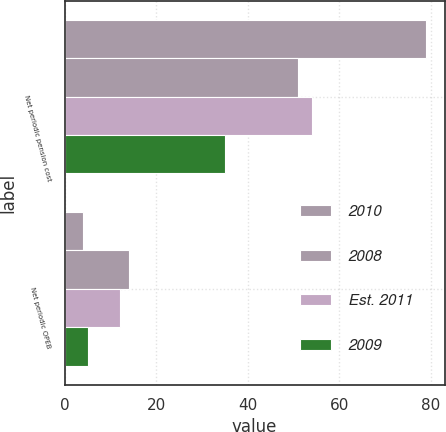Convert chart. <chart><loc_0><loc_0><loc_500><loc_500><stacked_bar_chart><ecel><fcel>Net periodic pension cost<fcel>Net periodic OPEB<nl><fcel>2010<fcel>79<fcel>4<nl><fcel>2008<fcel>51<fcel>14<nl><fcel>Est. 2011<fcel>54<fcel>12<nl><fcel>2009<fcel>35<fcel>5<nl></chart> 